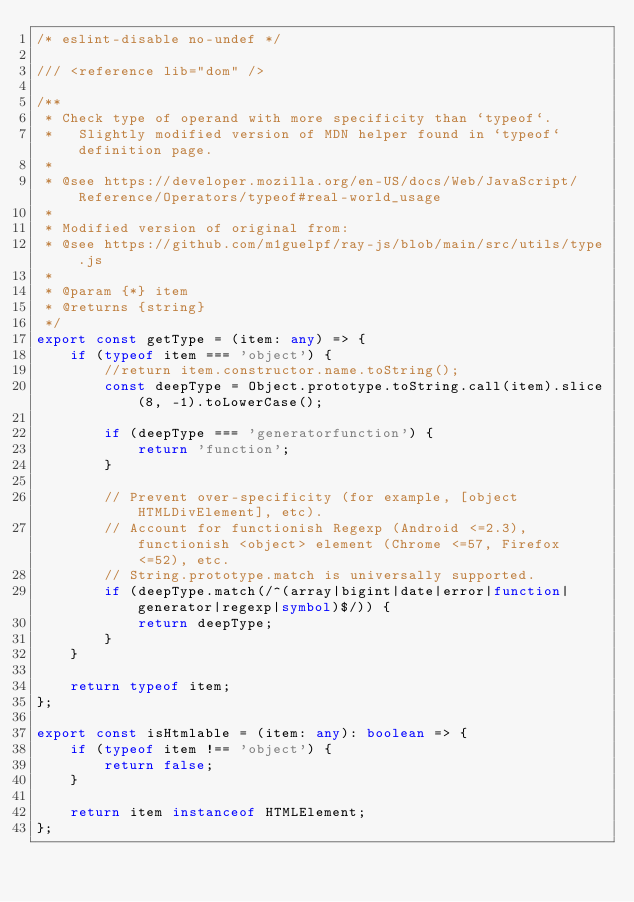<code> <loc_0><loc_0><loc_500><loc_500><_TypeScript_>/* eslint-disable no-undef */

/// <reference lib="dom" />

/**
 * Check type of operand with more specificity than `typeof`.
 *   Slightly modified version of MDN helper found in `typeof` definition page.
 *
 * @see https://developer.mozilla.org/en-US/docs/Web/JavaScript/Reference/Operators/typeof#real-world_usage
 *
 * Modified version of original from:
 * @see https://github.com/m1guelpf/ray-js/blob/main/src/utils/type.js
 *
 * @param {*} item
 * @returns {string}
 */
export const getType = (item: any) => {
    if (typeof item === 'object') {
        //return item.constructor.name.toString();
        const deepType = Object.prototype.toString.call(item).slice(8, -1).toLowerCase();

        if (deepType === 'generatorfunction') {
            return 'function';
        }

        // Prevent over-specificity (for example, [object HTMLDivElement], etc).
        // Account for functionish Regexp (Android <=2.3), functionish <object> element (Chrome <=57, Firefox <=52), etc.
        // String.prototype.match is universally supported.
        if (deepType.match(/^(array|bigint|date|error|function|generator|regexp|symbol)$/)) {
            return deepType;
        }
    }

    return typeof item;
};

export const isHtmlable = (item: any): boolean => {
    if (typeof item !== 'object') {
        return false;
    }

    return item instanceof HTMLElement;
};
</code> 